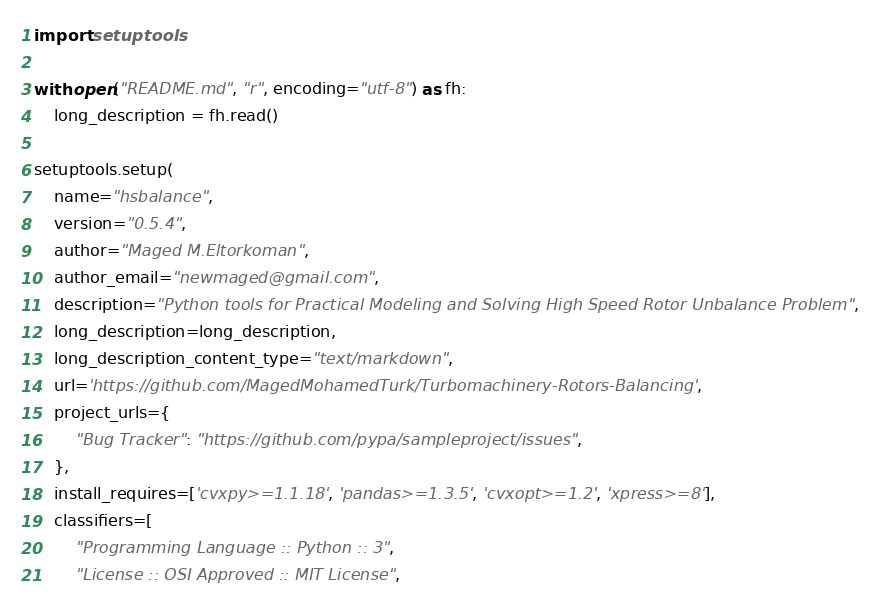Convert code to text. <code><loc_0><loc_0><loc_500><loc_500><_Python_>import setuptools

with open("README.md", "r", encoding="utf-8") as fh:
    long_description = fh.read()

setuptools.setup(
    name="hsbalance",
    version="0.5.4",
    author="Maged M.Eltorkoman",
    author_email="newmaged@gmail.com",
    description="Python tools for Practical Modeling and Solving High Speed Rotor Unbalance Problem",
    long_description=long_description,
    long_description_content_type="text/markdown",
    url='https://github.com/MagedMohamedTurk/Turbomachinery-Rotors-Balancing',
    project_urls={
        "Bug Tracker": "https://github.com/pypa/sampleproject/issues",
    },
    install_requires=['cvxpy>=1.1.18', 'pandas>=1.3.5', 'cvxopt>=1.2', 'xpress>=8'],
    classifiers=[
        "Programming Language :: Python :: 3",
        "License :: OSI Approved :: MIT License",</code> 